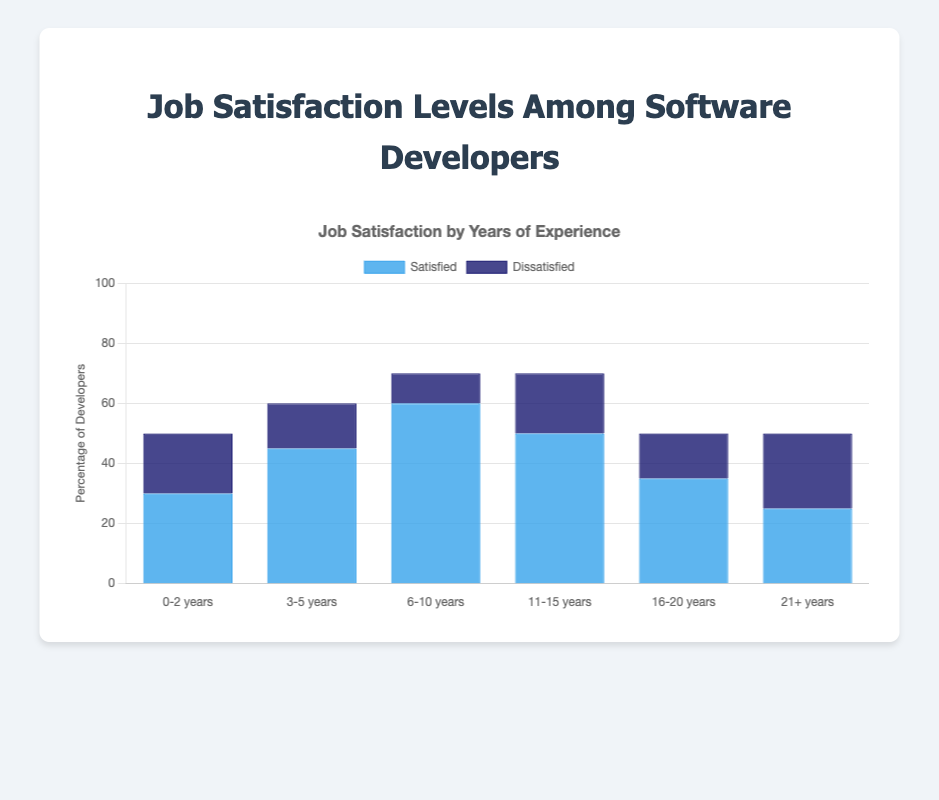What is the satisfaction level of developers with 6-10 years of experience? The bar representing satisfied developers with 6-10 years of experience is 60.
Answer: 60 How many developers with 0-2 years of experience are dissatisfied? The bar representing dissatisfied developers with 0-2 years of experience is 20.
Answer: 20 Which experience range has the largest number of satisfied developers? The tallest bar labeled "Satisfied" is for developers with 6-10 years of experience, with a value of 60.
Answer: 6-10 years Compare the satisfaction levels of developers with 16-20 years of experience versus those with 0-2 years of experience. Which group has higher satisfaction? The bar for 16-20 years has 35 satisfied developers, while the bar for 0-2 years has 30 satisfied developers.
Answer: 16-20 years What is the total number of developers dissatisfied across all experience ranges? Sum the values for dissatisfied developers: 20 (0-2 years) + 15 (3-5 years) + 10 (6-10 years) + 20 (11-15 years) + 15 (16-20 years) + 25 (21+ years) = 105.
Answer: 105 What experience range has the equal number of satisfied and dissatisfied developers? The bars representing satisfied and dissatisfied developers for the range 21+ years are both at 25.
Answer: 21+ years Which experience range has the smallest difference between satisfied and dissatisfied developers? The differences are:
0-2 years: 30 - 20 = 10
3-5 years: 45 - 15 = 30
6-10 years: 60 - 10 = 50
11-15 years: 50 - 20 = 30
16-20 years: 35 - 15 = 20
21+ years: 25 - 25 = 0
The smallest difference is in the range 21+ years.
Answer: 21+ years Which bar color represents dissatisfied developers? The dissatisfied developers are depicted using the dark blue bars.
Answer: Dark blue Is there any experience range where the number of satisfied developers is exactly double the number of dissatisfied developers? For the range 6-10 years, satisfied developers are 60 and dissatisfied are 10, which means satisfied developers are exactly 6 times the dissatisfied. Compare all:
0-2 years: Not double (30 vs 20)
3-5 years: Not double (45 vs 15)
6-10 years: 60 is not double 10
11-15 years: Not double (50 vs 20)
16-20 years: Not double (35 vs 15)
21+ years: Not double (25 vs 25)
No, there is no such range.
Answer: No 